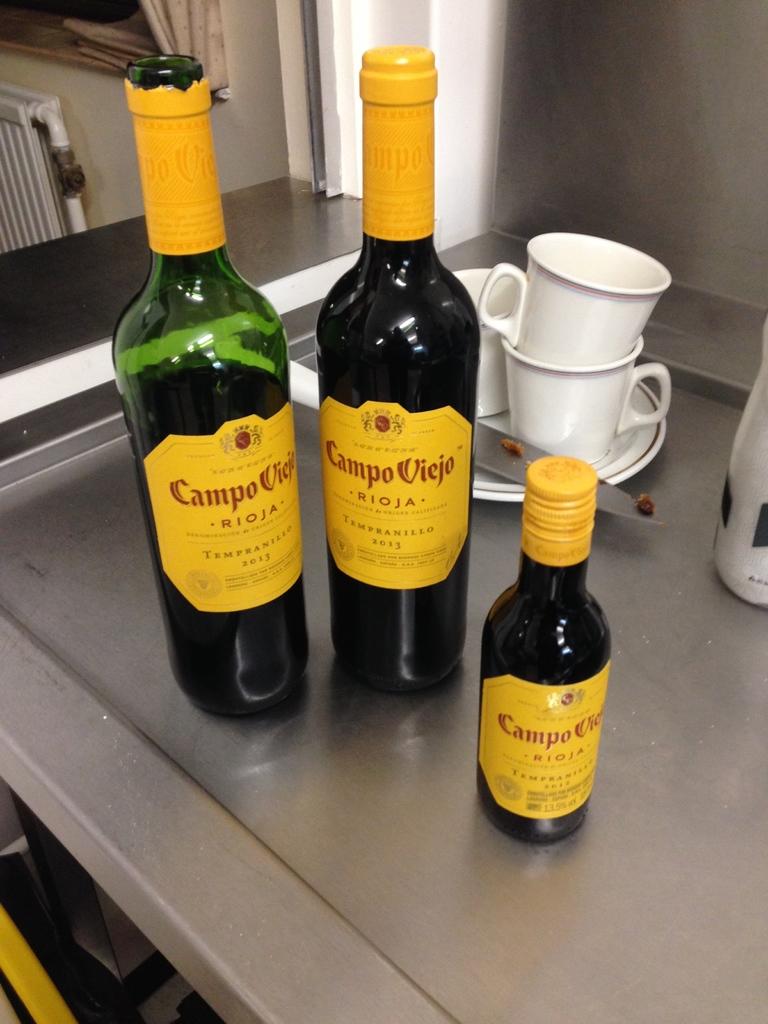What brand wine is this?
Your answer should be compact. Campo viejo. What year was the wine made?
Make the answer very short. 2013. 